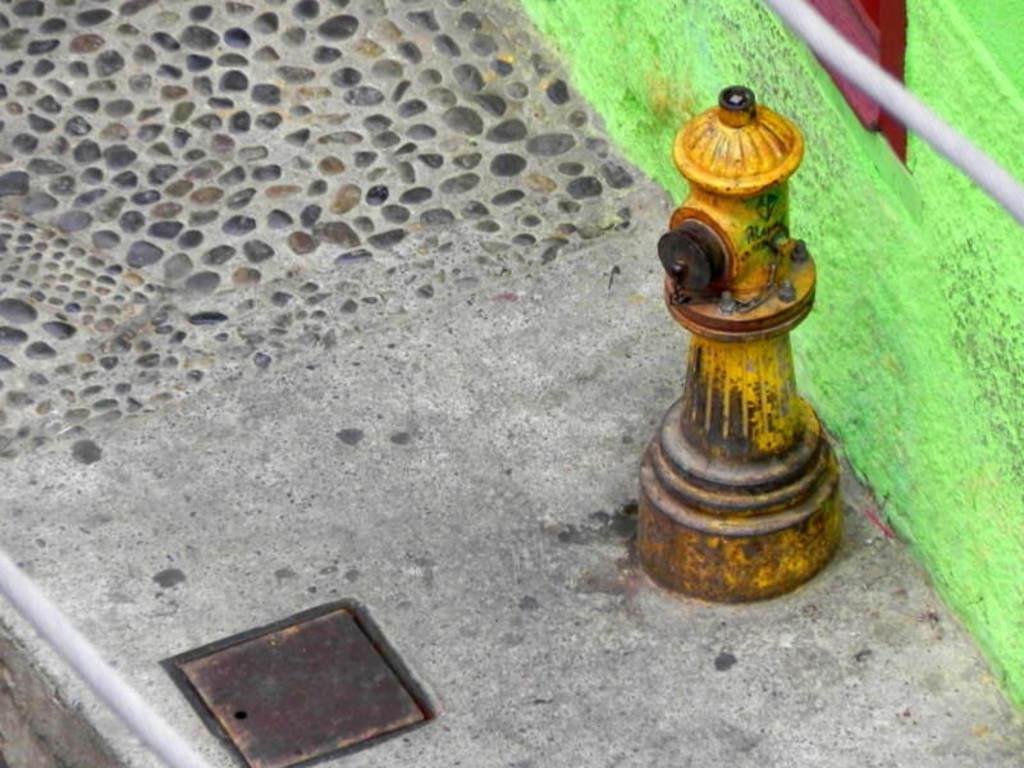Please provide a concise description of this image. In this image there is a fire hydrant on a pavement, beside that there is a wall. 